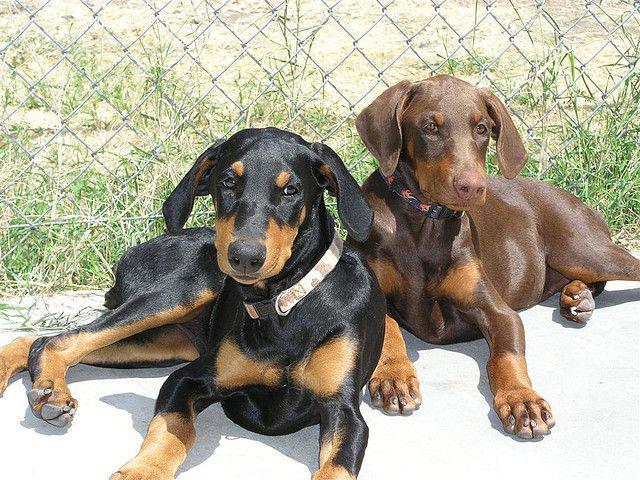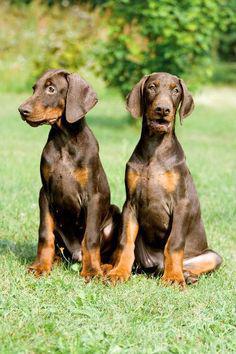The first image is the image on the left, the second image is the image on the right. For the images displayed, is the sentence "The left image includes side-by-side, identically-posed, forward-facing dobermans with erect pointy ears, and the right image contains two dobermans with floppy ears." factually correct? Answer yes or no. No. The first image is the image on the left, the second image is the image on the right. Analyze the images presented: Is the assertion "A darker colored dog is lying next to a lighter colored one of the same breed in at least one image." valid? Answer yes or no. Yes. 